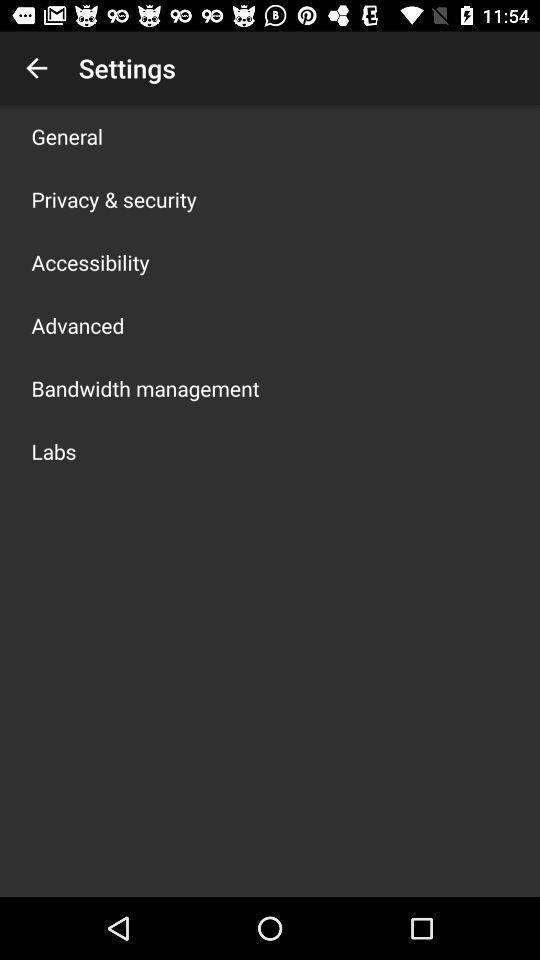Tell me about the visual elements in this screen capture. Settings menu list for an app. 